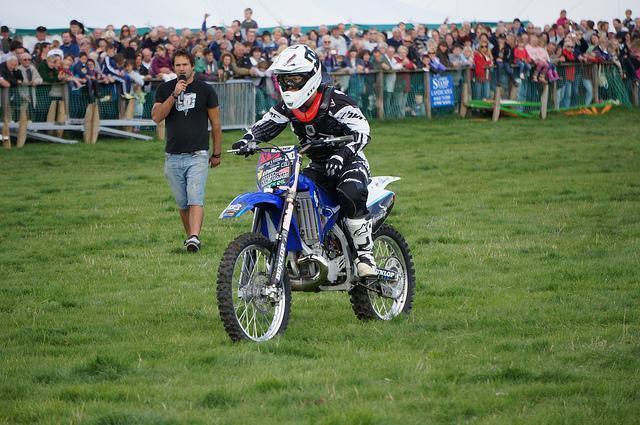How many motorcycles are in the picture?
Give a very brief answer. 1. How many people are in the photo?
Give a very brief answer. 3. 